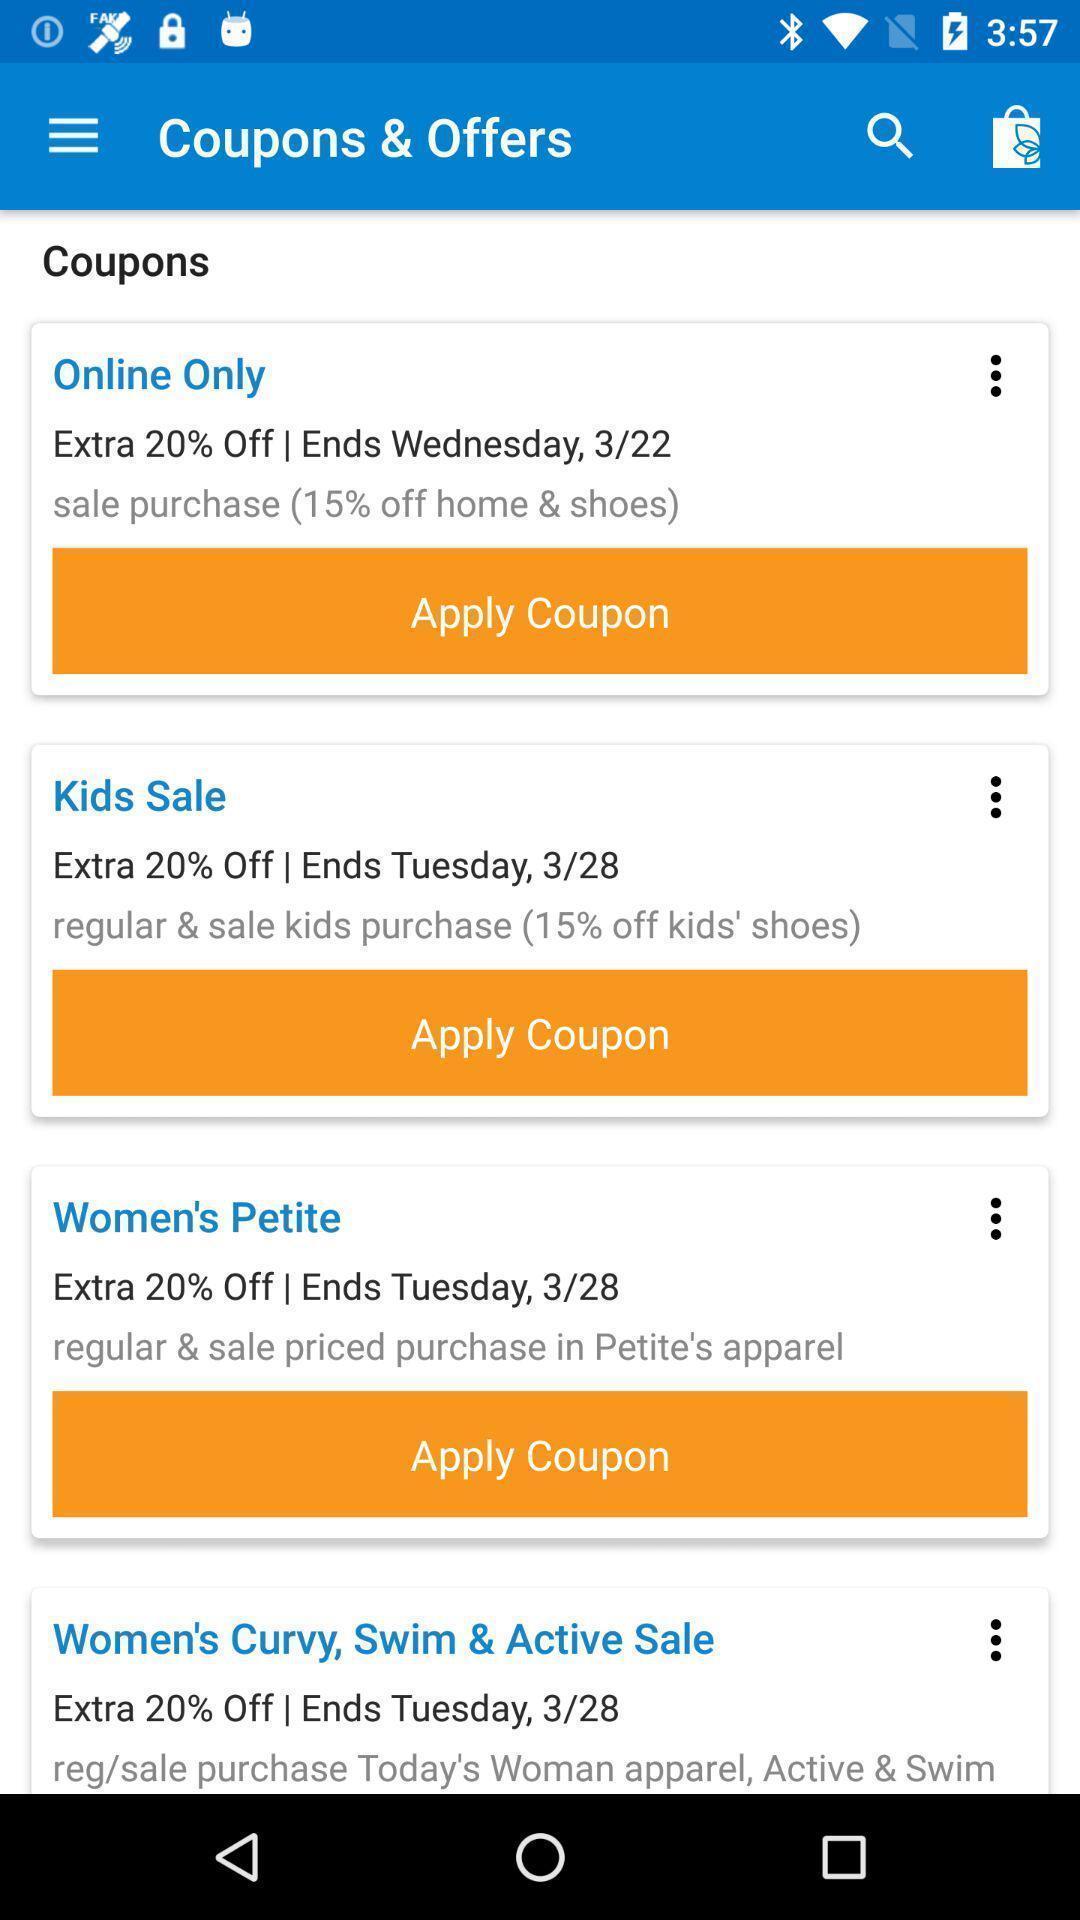What can you discern from this picture? Page showing options arel shopping app. 